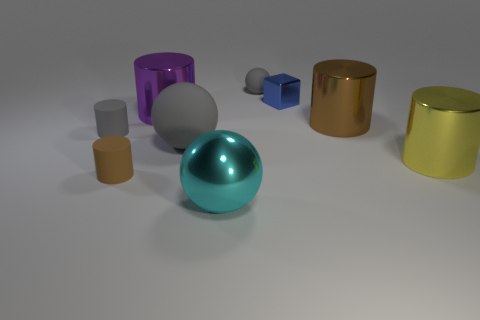What is the material of the cyan object?
Give a very brief answer. Metal. Does the matte sphere behind the large purple cylinder have the same color as the matte cylinder that is behind the large yellow cylinder?
Your answer should be very brief. Yes. Are there more large brown metal cylinders than big brown shiny spheres?
Provide a succinct answer. Yes. What number of matte cylinders are the same color as the small rubber sphere?
Ensure brevity in your answer.  1. The other big thing that is the same shape as the large rubber thing is what color?
Your answer should be very brief. Cyan. There is a large cylinder that is to the right of the tiny metal block and behind the gray cylinder; what is it made of?
Make the answer very short. Metal. Do the brown object that is to the left of the small block and the big sphere behind the large yellow thing have the same material?
Offer a very short reply. Yes. What size is the brown matte object?
Make the answer very short. Small. What size is the other gray thing that is the same shape as the large rubber object?
Provide a short and direct response. Small. How many gray matte objects are in front of the tiny gray matte cylinder?
Offer a very short reply. 1. 